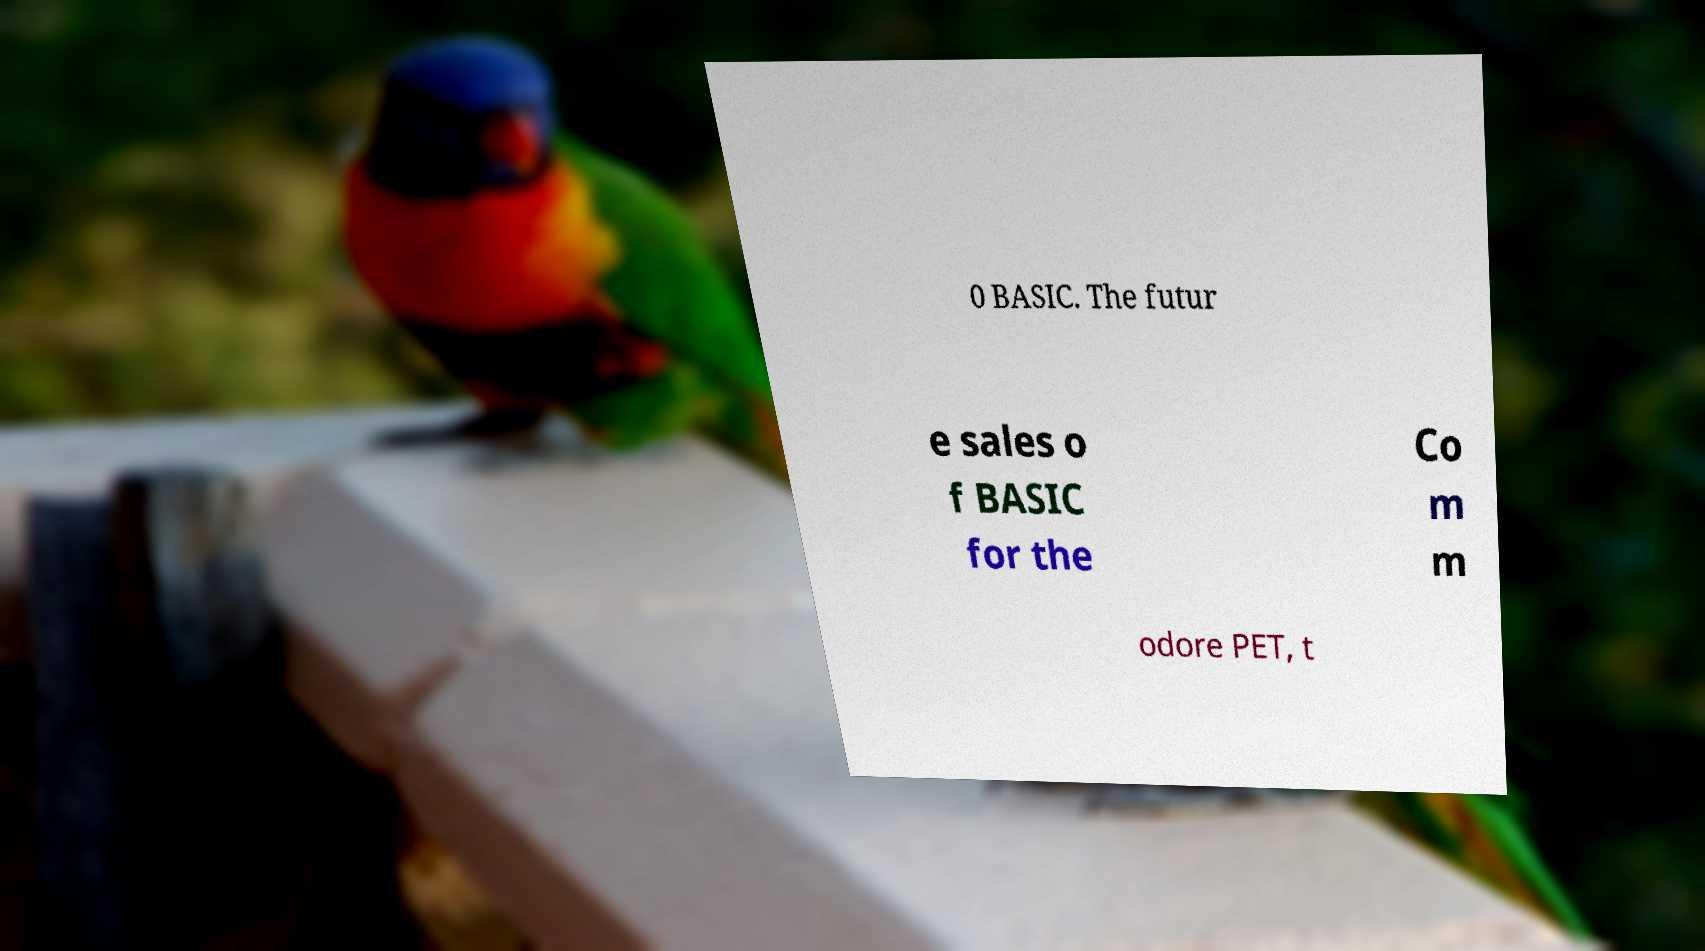Please identify and transcribe the text found in this image. 0 BASIC. The futur e sales o f BASIC for the Co m m odore PET, t 